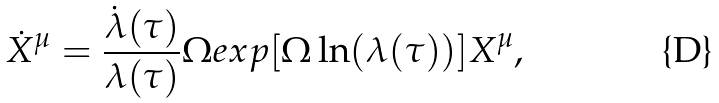<formula> <loc_0><loc_0><loc_500><loc_500>\dot { X } ^ { \mu } = \frac { \dot { \lambda } ( \tau ) } { \lambda ( \tau ) } \Omega e x p [ \Omega \ln ( \lambda ( \tau ) ) ] X ^ { \mu } ,</formula> 